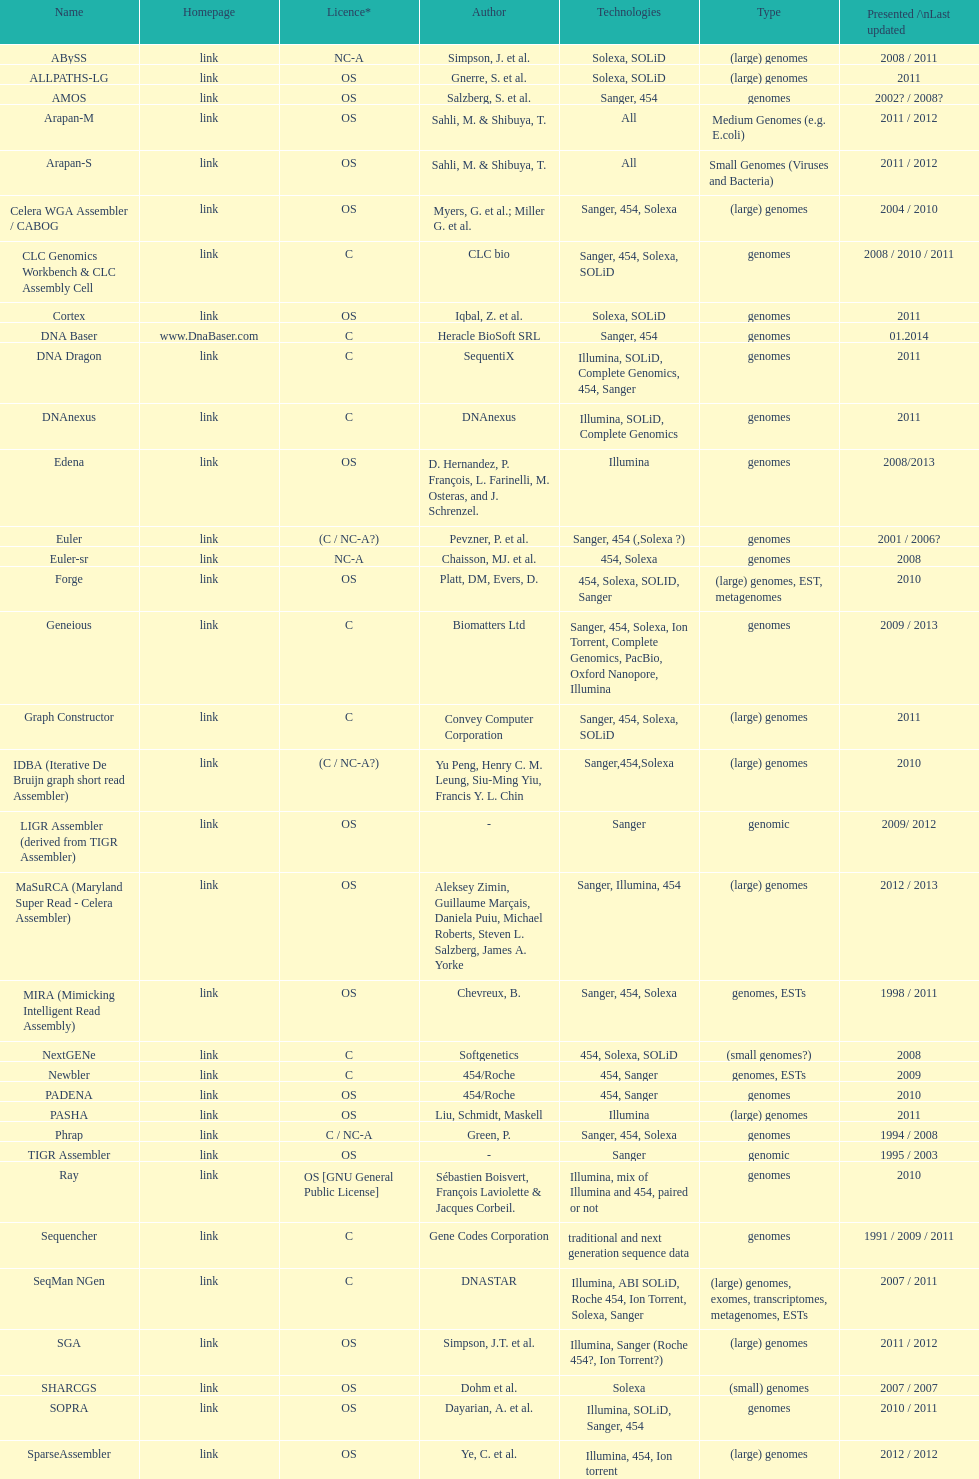What is the newest display or modified? DNA Baser. 